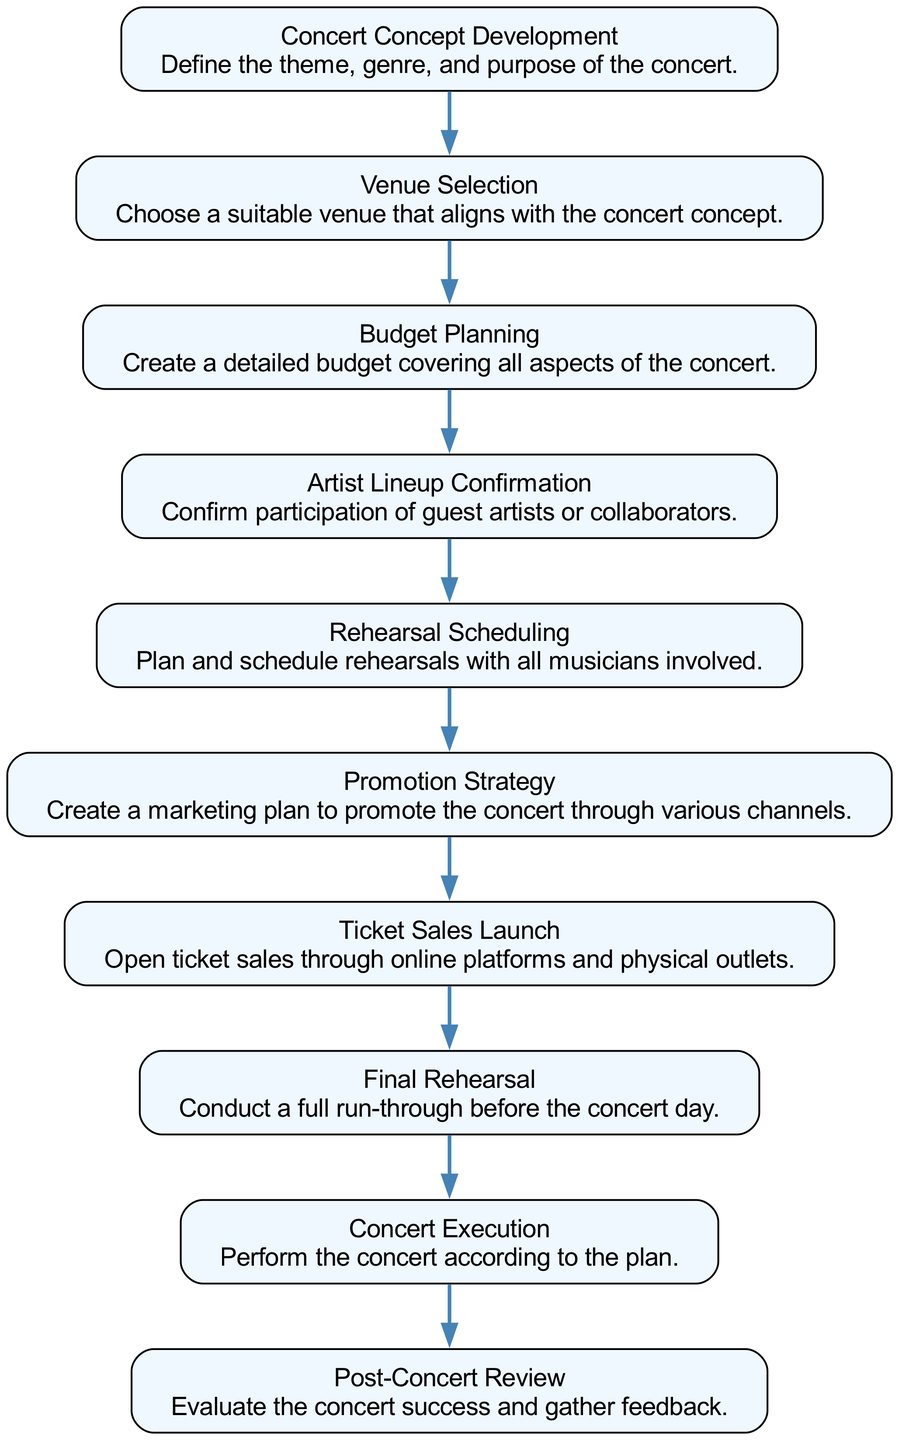What is the first step in organizing a concert? The first step in the flow chart is "Concert Concept Development," which is where the theme, genre, and purpose of the concert are defined.
Answer: Concert Concept Development How many nodes are there in the diagram? The diagram contains 10 nodes, each representing a step in the concert organization process.
Answer: 10 What step comes after Budget Planning? After "Budget Planning," the next step in the flow chart is "Artist Lineup Confirmation," where the participation of guest artists is confirmed.
Answer: Artist Lineup Confirmation Which step has the description "Evaluate the concert success and gather feedback."? This description corresponds to the "Post-Concert Review," which assesses the success of the concert and gathers audience feedback.
Answer: Post-Concert Review What is the last step in the concert organization process? The last step depicted in the flow chart is "Post-Concert Review," indicating the conclusion of the concert organization journey.
Answer: Post-Concert Review Which two steps come before Concert Execution? The steps that come before "Concert Execution" are "Final Rehearsal" and "Ticket Sales Launch," indicating that both need to be completed before performing the concert.
Answer: Final Rehearsal and Ticket Sales Launch What is the relationship between Venue Selection and Budget Planning? "Venue Selection" and "Budget Planning" are sequential steps in the chart; "Venue Selection" occurs before "Budget Planning," indicating that the venue choice impacts budget considerations.
Answer: Sequential What step involves "Create a marketing plan to promote the concert through various channels"? This task is part of the "Promotion Strategy" step, which aims to effectively market the concert to the audience.
Answer: Promotion Strategy What action is taken immediately after Ticket Sales Launch? The action taken immediately after "Ticket Sales Launch" is "Final Rehearsal," indicating preparation activities continue after ticket sales commence.
Answer: Final Rehearsal 